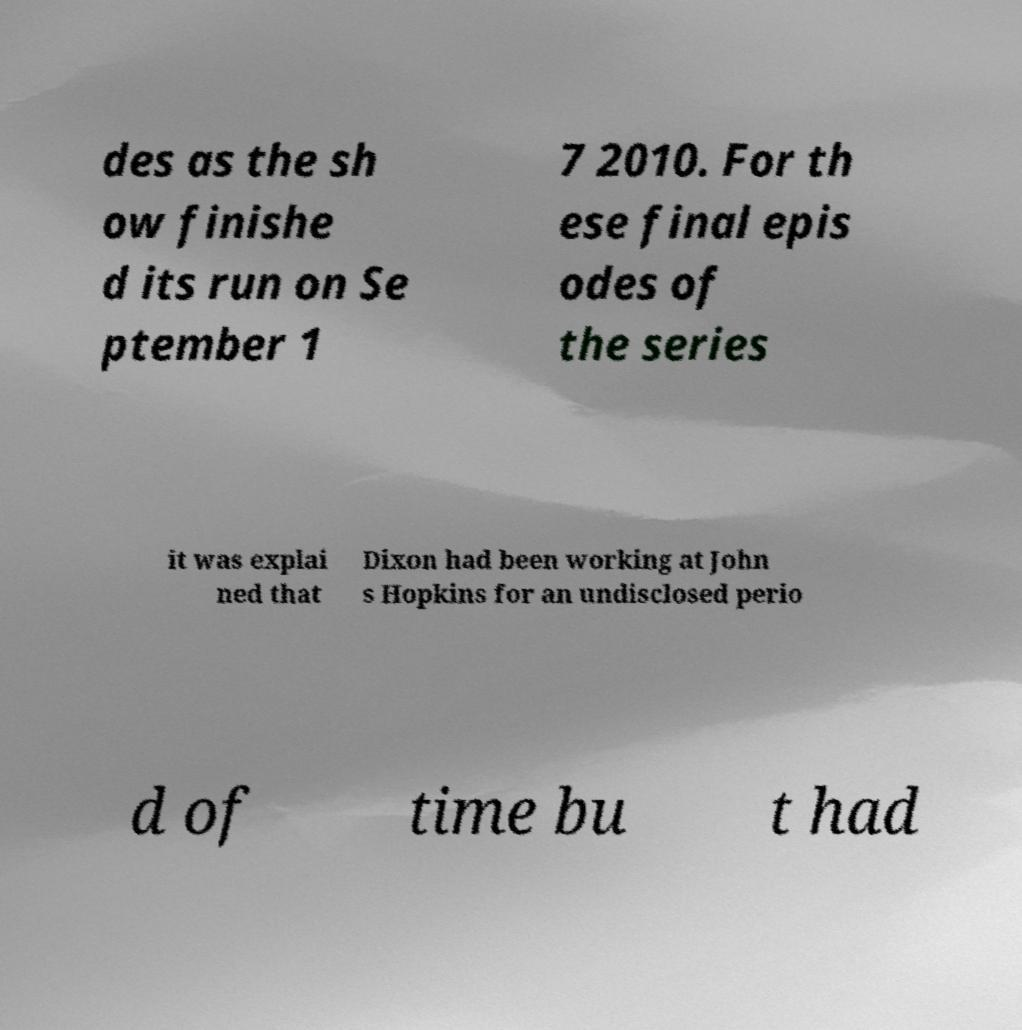Can you accurately transcribe the text from the provided image for me? des as the sh ow finishe d its run on Se ptember 1 7 2010. For th ese final epis odes of the series it was explai ned that Dixon had been working at John s Hopkins for an undisclosed perio d of time bu t had 